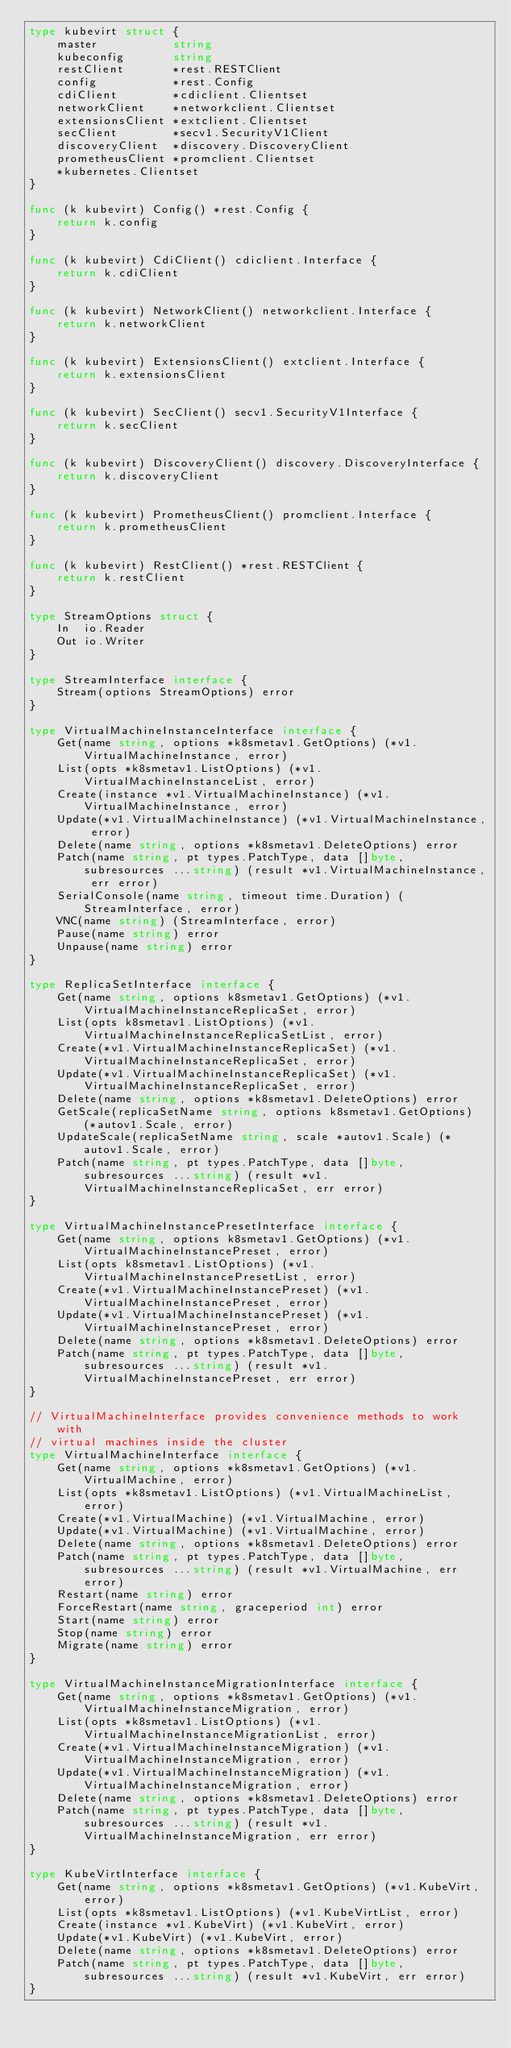<code> <loc_0><loc_0><loc_500><loc_500><_Go_>type kubevirt struct {
	master           string
	kubeconfig       string
	restClient       *rest.RESTClient
	config           *rest.Config
	cdiClient        *cdiclient.Clientset
	networkClient    *networkclient.Clientset
	extensionsClient *extclient.Clientset
	secClient        *secv1.SecurityV1Client
	discoveryClient  *discovery.DiscoveryClient
	prometheusClient *promclient.Clientset
	*kubernetes.Clientset
}

func (k kubevirt) Config() *rest.Config {
	return k.config
}

func (k kubevirt) CdiClient() cdiclient.Interface {
	return k.cdiClient
}

func (k kubevirt) NetworkClient() networkclient.Interface {
	return k.networkClient
}

func (k kubevirt) ExtensionsClient() extclient.Interface {
	return k.extensionsClient
}

func (k kubevirt) SecClient() secv1.SecurityV1Interface {
	return k.secClient
}

func (k kubevirt) DiscoveryClient() discovery.DiscoveryInterface {
	return k.discoveryClient
}

func (k kubevirt) PrometheusClient() promclient.Interface {
	return k.prometheusClient
}

func (k kubevirt) RestClient() *rest.RESTClient {
	return k.restClient
}

type StreamOptions struct {
	In  io.Reader
	Out io.Writer
}

type StreamInterface interface {
	Stream(options StreamOptions) error
}

type VirtualMachineInstanceInterface interface {
	Get(name string, options *k8smetav1.GetOptions) (*v1.VirtualMachineInstance, error)
	List(opts *k8smetav1.ListOptions) (*v1.VirtualMachineInstanceList, error)
	Create(instance *v1.VirtualMachineInstance) (*v1.VirtualMachineInstance, error)
	Update(*v1.VirtualMachineInstance) (*v1.VirtualMachineInstance, error)
	Delete(name string, options *k8smetav1.DeleteOptions) error
	Patch(name string, pt types.PatchType, data []byte, subresources ...string) (result *v1.VirtualMachineInstance, err error)
	SerialConsole(name string, timeout time.Duration) (StreamInterface, error)
	VNC(name string) (StreamInterface, error)
	Pause(name string) error
	Unpause(name string) error
}

type ReplicaSetInterface interface {
	Get(name string, options k8smetav1.GetOptions) (*v1.VirtualMachineInstanceReplicaSet, error)
	List(opts k8smetav1.ListOptions) (*v1.VirtualMachineInstanceReplicaSetList, error)
	Create(*v1.VirtualMachineInstanceReplicaSet) (*v1.VirtualMachineInstanceReplicaSet, error)
	Update(*v1.VirtualMachineInstanceReplicaSet) (*v1.VirtualMachineInstanceReplicaSet, error)
	Delete(name string, options *k8smetav1.DeleteOptions) error
	GetScale(replicaSetName string, options k8smetav1.GetOptions) (*autov1.Scale, error)
	UpdateScale(replicaSetName string, scale *autov1.Scale) (*autov1.Scale, error)
	Patch(name string, pt types.PatchType, data []byte, subresources ...string) (result *v1.VirtualMachineInstanceReplicaSet, err error)
}

type VirtualMachineInstancePresetInterface interface {
	Get(name string, options k8smetav1.GetOptions) (*v1.VirtualMachineInstancePreset, error)
	List(opts k8smetav1.ListOptions) (*v1.VirtualMachineInstancePresetList, error)
	Create(*v1.VirtualMachineInstancePreset) (*v1.VirtualMachineInstancePreset, error)
	Update(*v1.VirtualMachineInstancePreset) (*v1.VirtualMachineInstancePreset, error)
	Delete(name string, options *k8smetav1.DeleteOptions) error
	Patch(name string, pt types.PatchType, data []byte, subresources ...string) (result *v1.VirtualMachineInstancePreset, err error)
}

// VirtualMachineInterface provides convenience methods to work with
// virtual machines inside the cluster
type VirtualMachineInterface interface {
	Get(name string, options *k8smetav1.GetOptions) (*v1.VirtualMachine, error)
	List(opts *k8smetav1.ListOptions) (*v1.VirtualMachineList, error)
	Create(*v1.VirtualMachine) (*v1.VirtualMachine, error)
	Update(*v1.VirtualMachine) (*v1.VirtualMachine, error)
	Delete(name string, options *k8smetav1.DeleteOptions) error
	Patch(name string, pt types.PatchType, data []byte, subresources ...string) (result *v1.VirtualMachine, err error)
	Restart(name string) error
	ForceRestart(name string, graceperiod int) error
	Start(name string) error
	Stop(name string) error
	Migrate(name string) error
}

type VirtualMachineInstanceMigrationInterface interface {
	Get(name string, options *k8smetav1.GetOptions) (*v1.VirtualMachineInstanceMigration, error)
	List(opts *k8smetav1.ListOptions) (*v1.VirtualMachineInstanceMigrationList, error)
	Create(*v1.VirtualMachineInstanceMigration) (*v1.VirtualMachineInstanceMigration, error)
	Update(*v1.VirtualMachineInstanceMigration) (*v1.VirtualMachineInstanceMigration, error)
	Delete(name string, options *k8smetav1.DeleteOptions) error
	Patch(name string, pt types.PatchType, data []byte, subresources ...string) (result *v1.VirtualMachineInstanceMigration, err error)
}

type KubeVirtInterface interface {
	Get(name string, options *k8smetav1.GetOptions) (*v1.KubeVirt, error)
	List(opts *k8smetav1.ListOptions) (*v1.KubeVirtList, error)
	Create(instance *v1.KubeVirt) (*v1.KubeVirt, error)
	Update(*v1.KubeVirt) (*v1.KubeVirt, error)
	Delete(name string, options *k8smetav1.DeleteOptions) error
	Patch(name string, pt types.PatchType, data []byte, subresources ...string) (result *v1.KubeVirt, err error)
}
</code> 